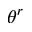Convert formula to latex. <formula><loc_0><loc_0><loc_500><loc_500>\theta ^ { r }</formula> 